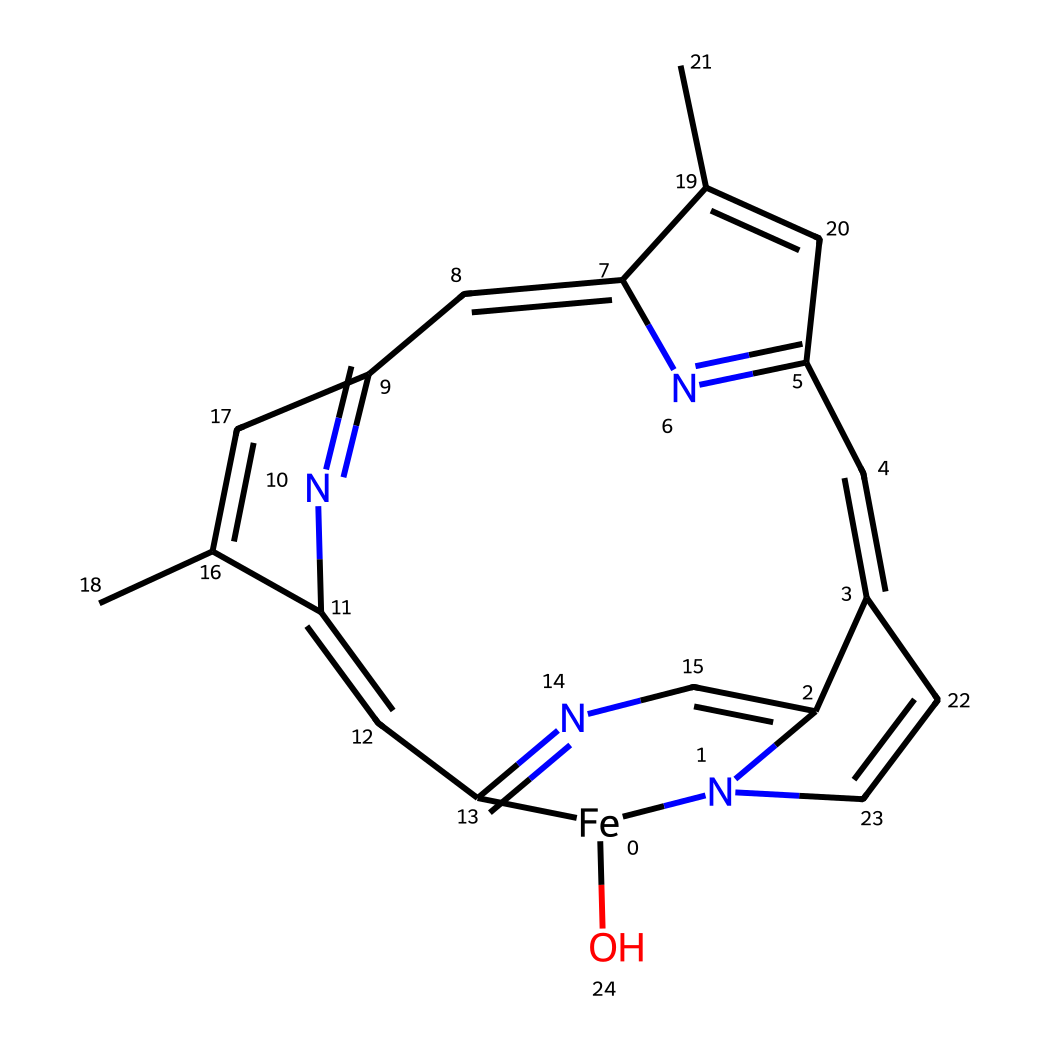how many iron atoms are present in the structure? The SMILES representation indicates the presence of one iron atom, which is represented by [Fe].
Answer: one what is the primary function of hemoglobin in blood? Hemoglobin's primary function is to transport oxygen from the lungs to the body's tissues.
Answer: transport oxygen which type of compound is hemoglobin classified as? Hemoglobin is classified as a coordination compound because it contains a metal ion (iron) bonded to multiple ligands (the nitrogen and carbon framework).
Answer: coordination compound how many nitrogen atoms are in the structure? By analyzing the SMILES representation, we can count a total of 6 nitrogen atoms. Each nitrogen is denoted by 'N' in the SMILES.
Answer: six what ligands are coordinated to the iron atom in hemoglobin? The ligands in hemoglobin that coordinate to iron include nitrogen-containing groups from the heme structure, specifically the nitrogen atoms in the porphyrin ring.
Answer: nitrogen ligands how does the presence of iron influence the oxygen-binding capability of hemoglobin? The presence of iron allows hemoglobin to form strong coordination bonds with oxygen molecules, significantly enhancing its oxygen transport capability.
Answer: enhances capability what type of bond is formed between the iron and oxygen in hemoglobin? The bond formed between iron and oxygen in hemoglobin is a coordinate covalent bond, where the iron atom shares one of its vacant orbitals with the oxygen molecule.
Answer: coordinate covalent bond 